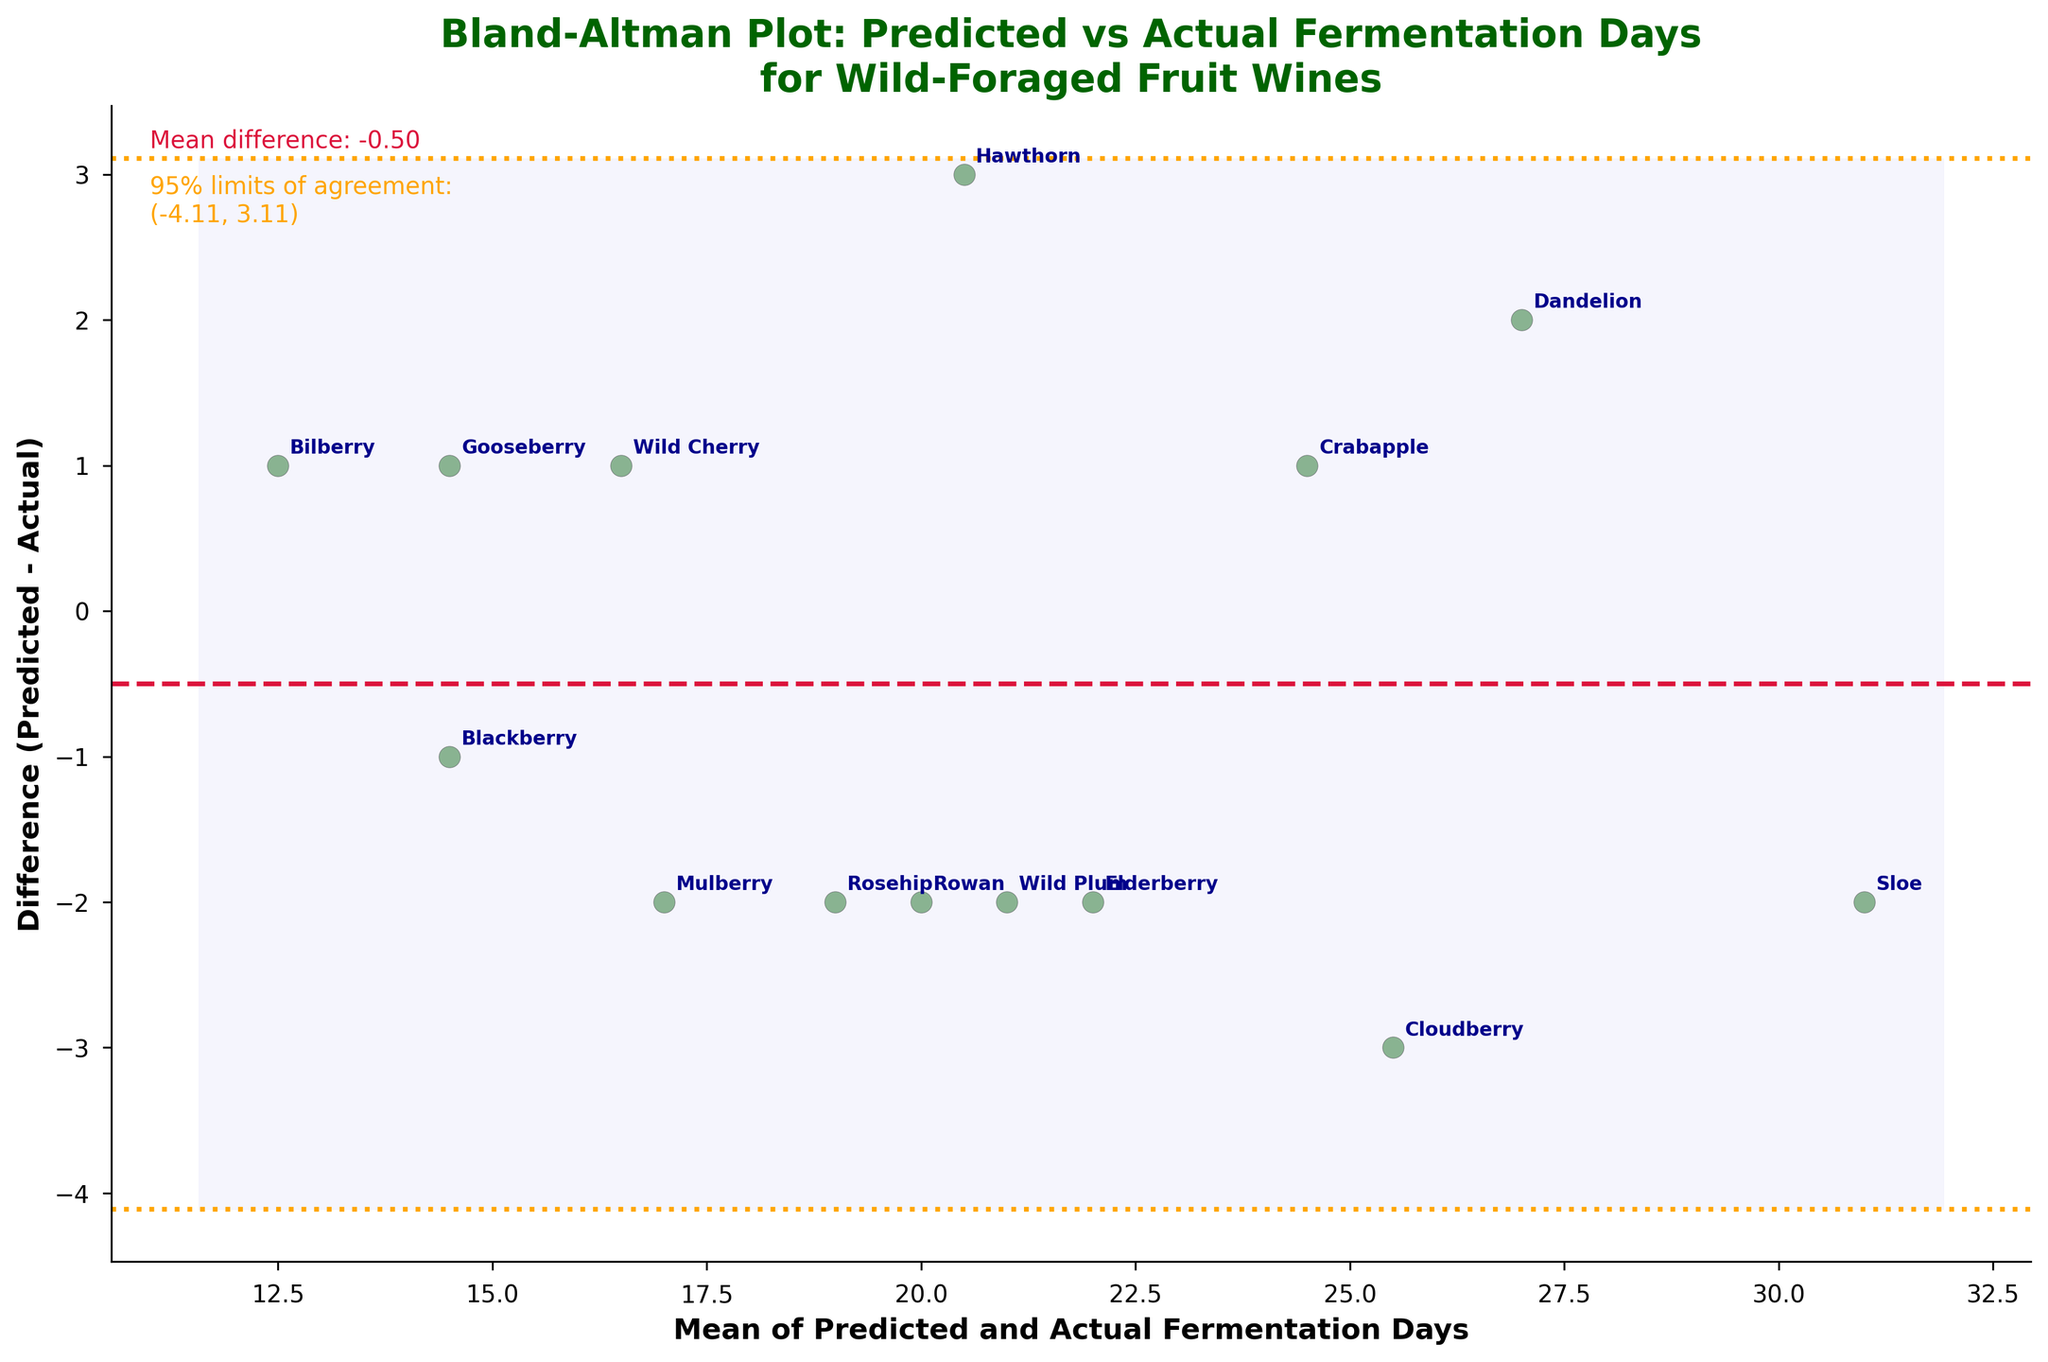What's the title of the plot? The title of the plot is displayed prominently at the top and summarizes what the plot is about—it reads "Bland-Altman Plot: Predicted vs Actual Fermentation Days for Wild-Foraged Fruit Wines".
Answer: Bland-Altman Plot: Predicted vs Actual Fermentation Days for Wild-Foraged Fruit Wines What does the x-axis represent? The x-axis label is shown at the bottom of the plot. It states "Mean of Predicted and Actual Fermentation Days," indicating it represents the average of predicted and actual fermentation days.
Answer: Mean of Predicted and Actual Fermentation Days What is the mean difference between predicted and actual fermentation days? The plot contains a textual annotation on the side, which states "Mean difference: -0.14". This provides the mean difference.
Answer: -0.14 What are the 95% limits of agreement? The plot text annotation lists the 95% limits of agreement. The text reads: "95% limits of agreement: (-3.98, 3.70)". This indicates the range of agreement.
Answer: (-3.98, 3.70) Which fruits have a positive difference between predicted and actual fermentation days? By identifying the points above the zero (horizontal) line in the plot, we can see which fruits have a positive difference. These fruits are Elderberry, Rosehip, Wild Plum, Rowan, Cloudberry.
Answer: Elderberry, Rosehip, Wild Plum, Rowan, Cloudberry What is the range of the differences shown on the y-axis? The y-axis represents the differences between predicted and actual fermentation days. The topmost point is at +4 (Sloe), and the bottommost point is at -3 (Hawthorn), giving a range of -3 to +4.
Answer: -3 to +4 How many fruits showed no difference in fermentation days? By counting the points on the zero line where the difference is zero, we see there is one fruit, Gooseberry, which showed no difference.
Answer: 1 What is the standard deviation of the differences? The plot doesn't explicitly state the standard deviation, but based on the 95% limits of agreement formula, \(1.96 \times \text{SD} = \text{upper limit} - \text{mean}\). Using the upper limit of 3.70 and mean of -0.14, \( 1.96 \times \text{SD} = 3.70 - (-0.14) = 3.84 \). Therefore, \( \text{SD} = \frac{3.84}{1.96} \approx 1.96 \).
Answer: 1.96 Which fruit has the largest negative difference and what is the value? The fruit with the largest negative difference is at the lowest point on the y-axis. Hawthorn is at approximately -3.
Answer: Hawthorn, -3 What color are the points representing the data? The points representing the data are colored dark green with black edges, according to the visual representation of the scatter points on the plot.
Answer: Dark green with black edges 